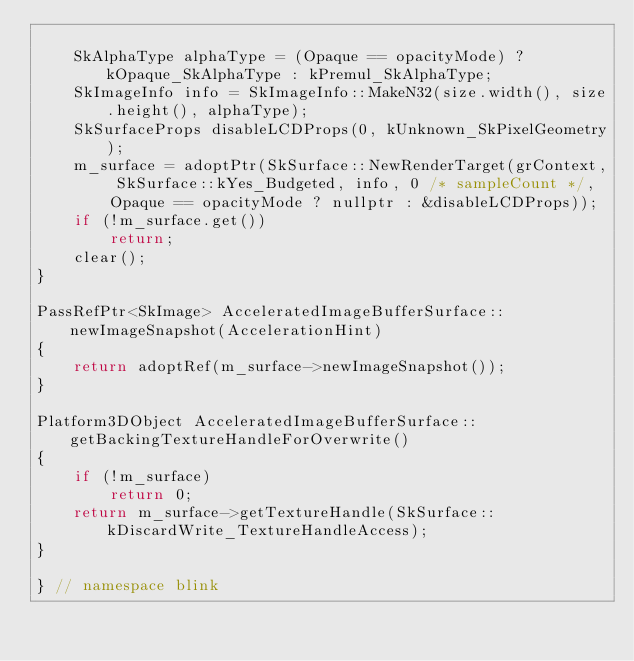Convert code to text. <code><loc_0><loc_0><loc_500><loc_500><_C++_>
    SkAlphaType alphaType = (Opaque == opacityMode) ? kOpaque_SkAlphaType : kPremul_SkAlphaType;
    SkImageInfo info = SkImageInfo::MakeN32(size.width(), size.height(), alphaType);
    SkSurfaceProps disableLCDProps(0, kUnknown_SkPixelGeometry);
    m_surface = adoptPtr(SkSurface::NewRenderTarget(grContext, SkSurface::kYes_Budgeted, info, 0 /* sampleCount */,
        Opaque == opacityMode ? nullptr : &disableLCDProps));
    if (!m_surface.get())
        return;
    clear();
}

PassRefPtr<SkImage> AcceleratedImageBufferSurface::newImageSnapshot(AccelerationHint)
{
    return adoptRef(m_surface->newImageSnapshot());
}

Platform3DObject AcceleratedImageBufferSurface::getBackingTextureHandleForOverwrite()
{
    if (!m_surface)
        return 0;
    return m_surface->getTextureHandle(SkSurface::kDiscardWrite_TextureHandleAccess);
}

} // namespace blink
</code> 